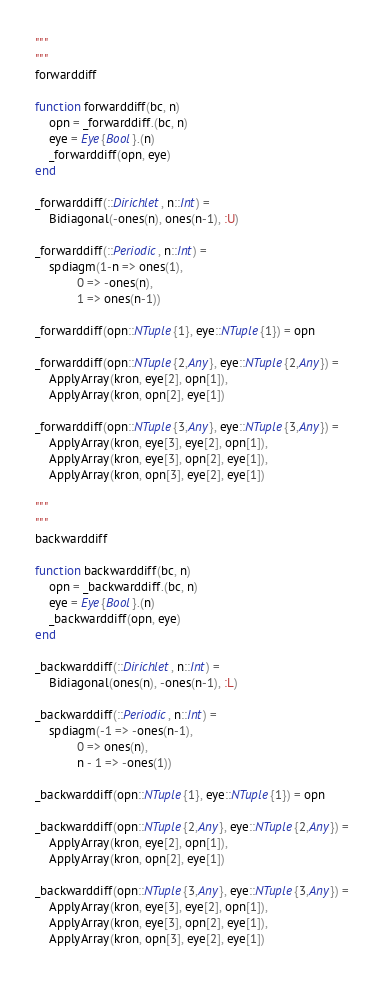Convert code to text. <code><loc_0><loc_0><loc_500><loc_500><_Julia_>"""
"""
forwarddiff

function forwarddiff(bc, n)
    opn = _forwarddiff.(bc, n)
    eye = Eye{Bool}.(n)
    _forwarddiff(opn, eye)
end

_forwarddiff(::Dirichlet, n::Int) =
    Bidiagonal(-ones(n), ones(n-1), :U)

_forwarddiff(::Periodic, n::Int) =
    spdiagm(1-n => ones(1),
            0 => -ones(n),
            1 => ones(n-1))

_forwarddiff(opn::NTuple{1}, eye::NTuple{1}) = opn

_forwarddiff(opn::NTuple{2,Any}, eye::NTuple{2,Any}) =
    ApplyArray(kron, eye[2], opn[1]),
    ApplyArray(kron, opn[2], eye[1])

_forwarddiff(opn::NTuple{3,Any}, eye::NTuple{3,Any}) =
    ApplyArray(kron, eye[3], eye[2], opn[1]),
    ApplyArray(kron, eye[3], opn[2], eye[1]),
    ApplyArray(kron, opn[3], eye[2], eye[1])

"""
"""
backwarddiff

function backwarddiff(bc, n)
    opn = _backwarddiff.(bc, n)
    eye = Eye{Bool}.(n)
    _backwarddiff(opn, eye)
end

_backwarddiff(::Dirichlet, n::Int) =
    Bidiagonal(ones(n), -ones(n-1), :L)

_backwarddiff(::Periodic, n::Int) =
    spdiagm(-1 => -ones(n-1),
            0 => ones(n),
            n - 1 => -ones(1))

_backwarddiff(opn::NTuple{1}, eye::NTuple{1}) = opn

_backwarddiff(opn::NTuple{2,Any}, eye::NTuple{2,Any}) =
    ApplyArray(kron, eye[2], opn[1]),
    ApplyArray(kron, opn[2], eye[1])

_backwarddiff(opn::NTuple{3,Any}, eye::NTuple{3,Any}) =
    ApplyArray(kron, eye[3], eye[2], opn[1]),
    ApplyArray(kron, eye[3], opn[2], eye[1]),
    ApplyArray(kron, opn[3], eye[2], eye[1])

</code> 